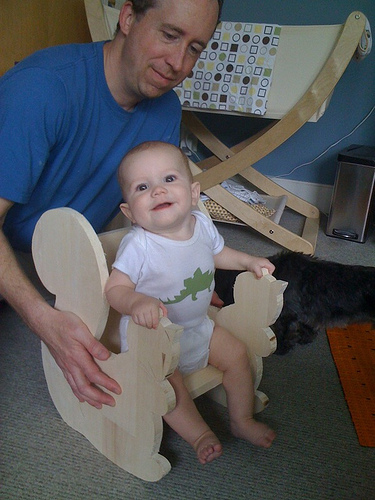<image>
Is the dinosaur on the wrist? No. The dinosaur is not positioned on the wrist. They may be near each other, but the dinosaur is not supported by or resting on top of the wrist. Where is the carpet in relation to the chair? Is it next to the chair? No. The carpet is not positioned next to the chair. They are located in different areas of the scene. Is there a chair in front of the man? Yes. The chair is positioned in front of the man, appearing closer to the camera viewpoint. 